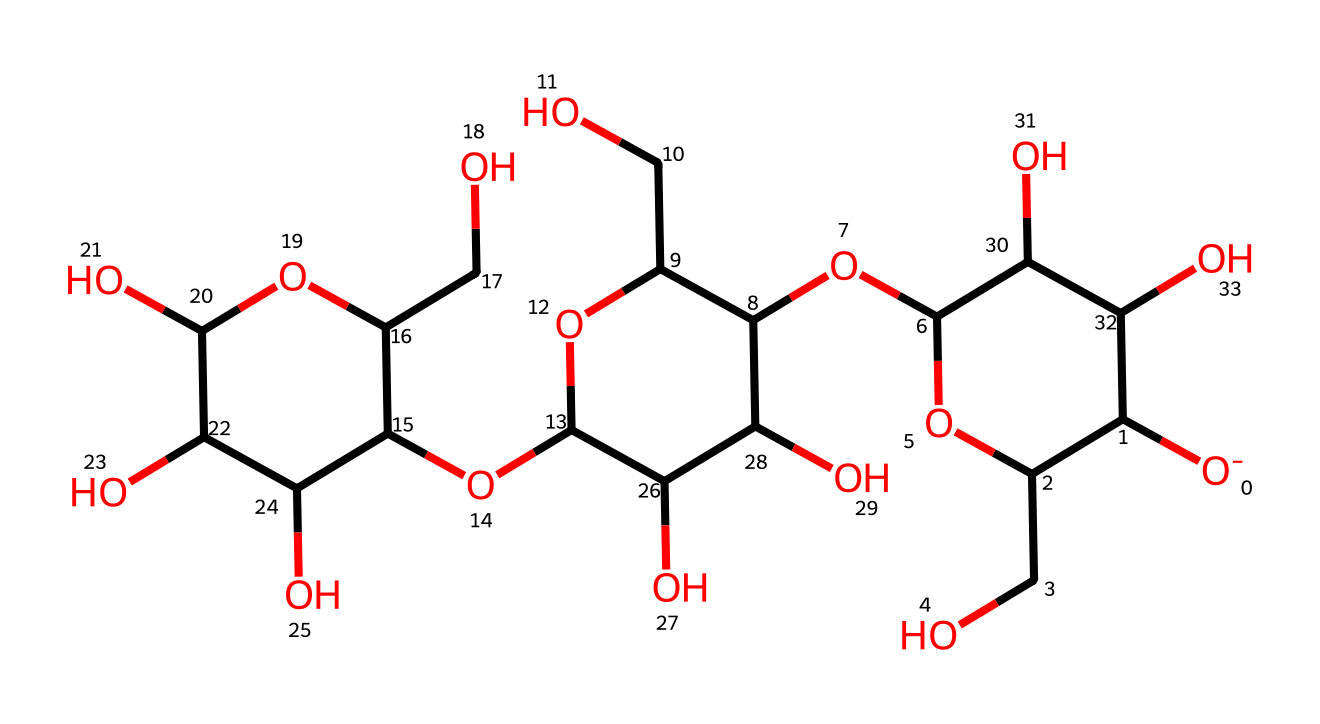How many carbon atoms are in this structure? By analyzing the SMILES representation, we can count the carbon (C) atoms that are present in the structure. Each branch and cyclic structure contributes to the total count, leading to a total of 12 carbon atoms in the full equation.
Answer: 12 How many hydroxyl (OH) groups are present? The SMILES code indicates the presence of several hydroxyl groups, which are denoted by the O atoms connected to C along with H. By carefully counting these in the structure, we find that there are 6 hydroxyl groups.
Answer: 6 What is the main type of polymer in this chemical? Given the structure defined by the SMILES, it follows the characteristics of a polysaccharide, specifically cellulose. Cellulose is known for its repeating glucose units linked by glycosidic bonds.
Answer: polysaccharide How many rings are in the chemical structure? The structure reveals multiple cyclic elements in the SMILES notation, which indicates the presence of ring structures. Upon close inspection, there are 3 ring structures within the polymer.
Answer: 3 Which element predominantly characterizes cellulose in this structure? In cellulose, the recurring presence of oxygen (O) atoms or hydroxyl groups is significant, as they determine its properties and stability. The largest proportion of the molecule consists of oxygen, confirming this element's dominant role.
Answer: oxygen What kind of bonds are mainly present between the glucose units? The repeating units in this SMILES indicate that the bonds between the glucose units correspond to glycosidic links, which are covalent in nature, connecting the sugar units together in a strong fashion.
Answer: glycosidic links 